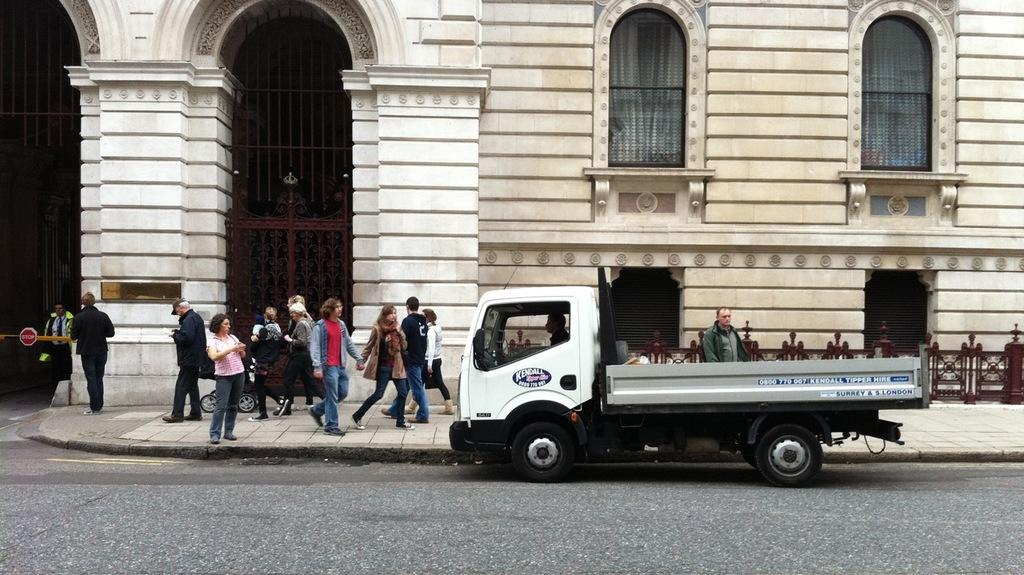What is the main subject of the image? There is a vehicle in the image. Who or what is inside the vehicle? A person is sitting in the vehicle. What can be seen in the background of the image? There are people walking on a pathway and a building visible in the background. How many roots can be seen growing from the woman's nose in the image? There is no woman or nose with roots in the image. 